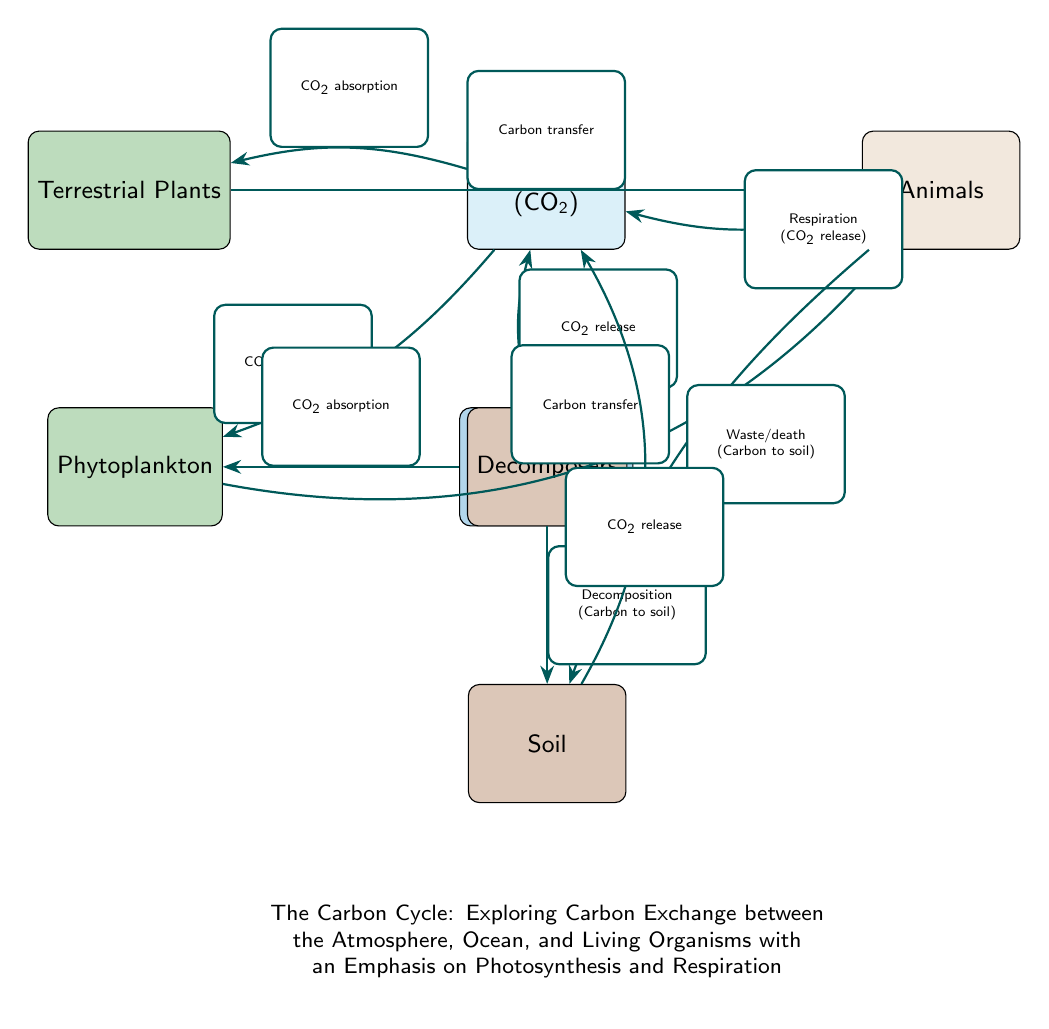What is the process indicated by the arrow from animals to the atmosphere? The diagram shows an arrow labeled "Respiration (CO2 release)" pointing from "Animals" to "Atmosphere", indicating that animals release carbon dioxide into the atmosphere through respiration.
Answer: Respiration (CO2 release) How many main components are illustrated in the carbon cycle? The diagram highlights five main components: Atmosphere, Ocean Surface, Phytoplankton, Terrestrial Plants, and Animals. By counting these elements, we find there are a total of five.
Answer: 5 What feedback mechanism is represented by the release of CO2 from soil to the atmosphere? The diagram includes an arrow labeled "CO2 release" from "Soil" to "Atmosphere", which indicates that carbon returns to the atmosphere from the soil. This illustrates a corrective feedback mechanism in the carbon cycle.
Answer: CO2 release What type of organisms absorb CO2 from the ocean? The diagram indicates that "Phytoplankton" absorb CO2 from the "Ocean Surface", which specifies that these organisms play a key role in carbon absorption in aquatic environments.
Answer: Phytoplankton Which process links terrestrial plants to the atmosphere? The diagram depicts an arrow labeled "CO2 absorption" from "Atmosphere" to "Terrestrial Plants", indicating that terrestrial plants take in carbon dioxide from the atmosphere through the process of photosynthesis.
Answer: CO2 absorption What happens to carbon from animals when they die or produce waste? The diagram shows an arrow labeled "Waste/death (Carbon to soil)" from "Animals" to "Soil". This indicates that when animals produce waste or die, carbon is transferred to the soil, where it can be reused in the carbon cycle.
Answer: Carbon to soil How does carbon in the ocean return to the atmosphere? The diagram shows an arrow labeled "CO2 release" from "Ocean Surface" to "Atmosphere", demonstrating that carbon can return to the atmosphere from the ocean, which is a critical part of the carbon exchange process.
Answer: CO2 release What is the relationship between phytoplankton and animals in this diagram? The diagram represents a connection labeled "Carbon transfer" from "Phytoplankton" to "Animals", indicating that carbon moves from phytoplankton to animals as part of the food web in the marine ecosystem.
Answer: Carbon transfer Which organisms act as decomposers in the carbon cycle? The diagram highlights the node labeled "Decomposers", which represents the organisms that break down dead material and return carbon to the soil, facilitating nutrient cycling within the ecosystem.
Answer: Decomposers 